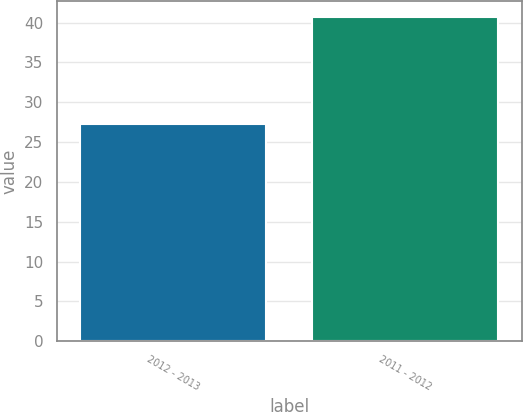Convert chart to OTSL. <chart><loc_0><loc_0><loc_500><loc_500><bar_chart><fcel>2012 - 2013<fcel>2011 - 2012<nl><fcel>27.3<fcel>40.7<nl></chart> 